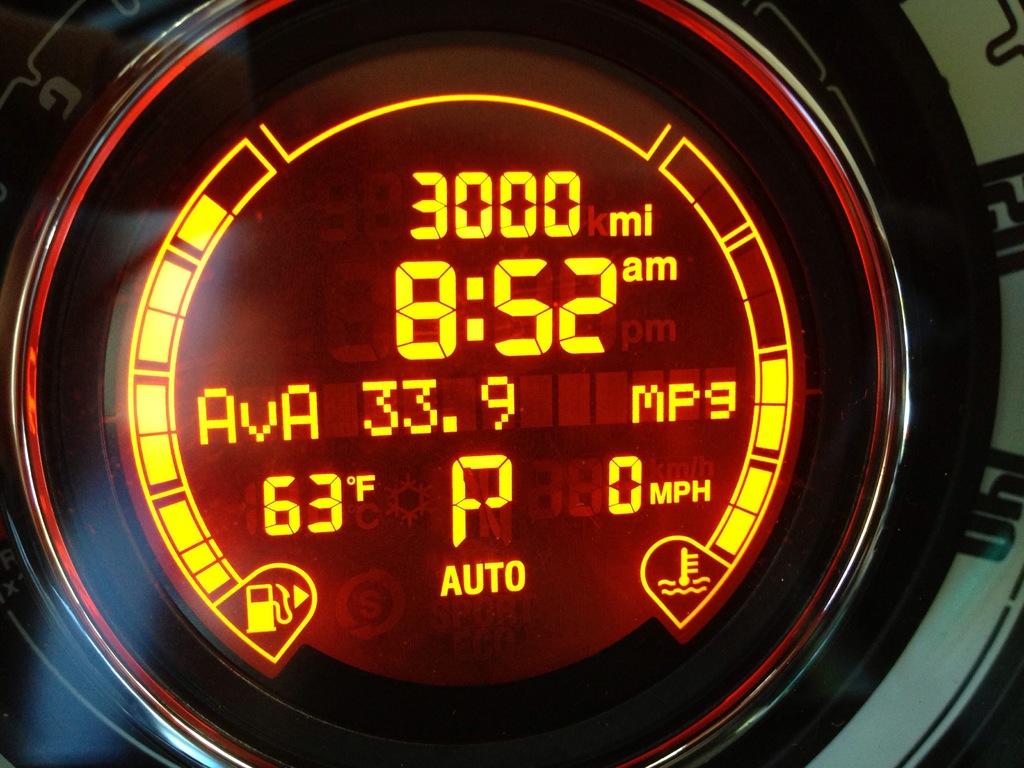What is the temperature?
Your response must be concise. 63. How much miles it says?
Ensure brevity in your answer.  3000. 